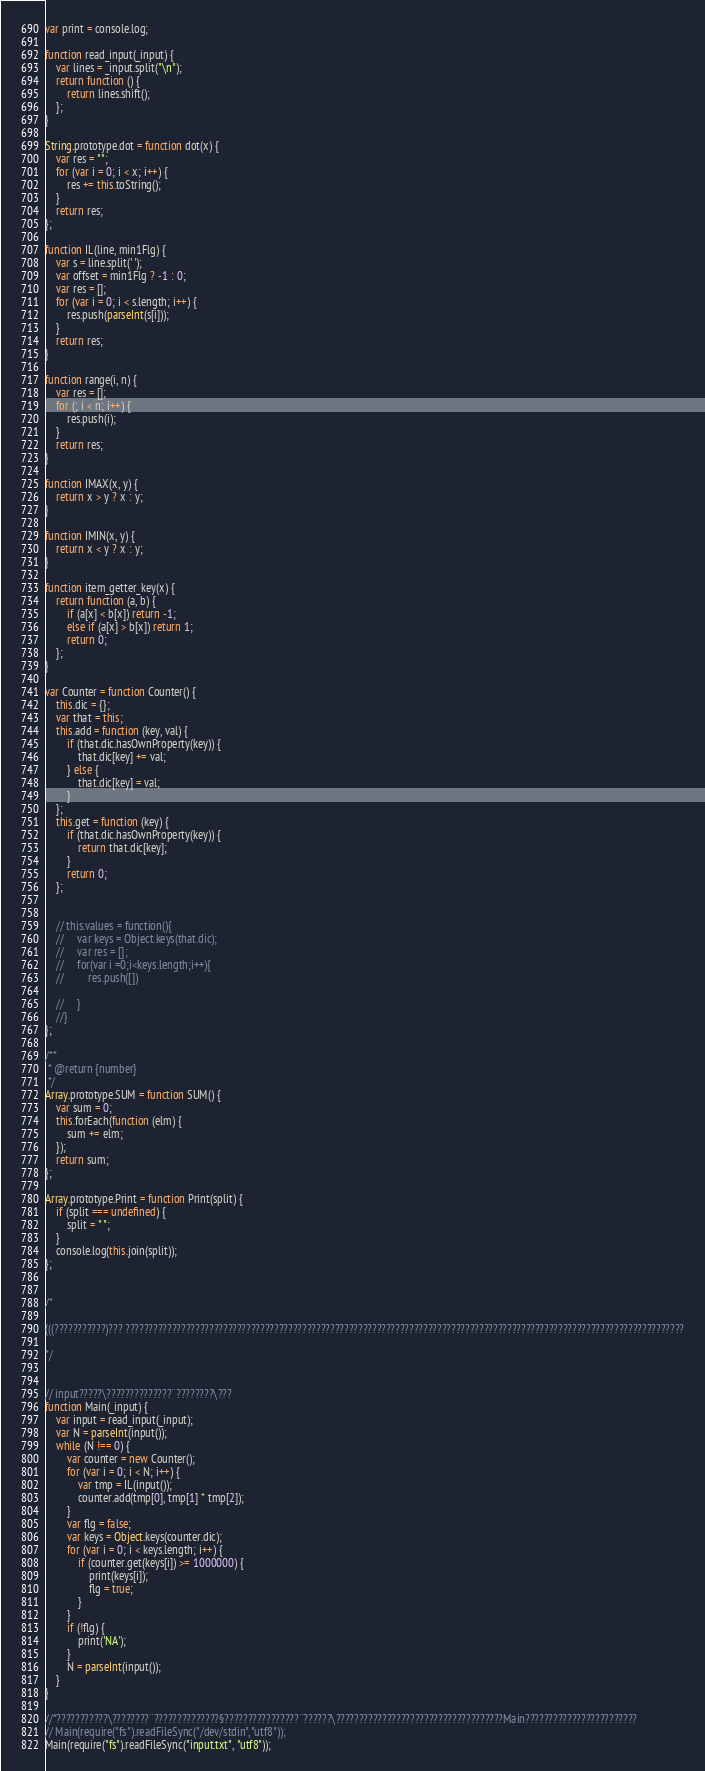<code> <loc_0><loc_0><loc_500><loc_500><_JavaScript_>var print = console.log;

function read_input(_input) {
    var lines = _input.split("\n");
    return function () {
        return lines.shift();
    };
}

String.prototype.dot = function dot(x) {
    var res = "";
    for (var i = 0; i < x; i++) {
        res += this.toString();
    }
    return res;
};

function IL(line, min1Flg) {
    var s = line.split(' ');
    var offset = min1Flg ? -1 : 0;
    var res = [];
    for (var i = 0; i < s.length; i++) {
        res.push(parseInt(s[i]));
    }
    return res;
}

function range(i, n) {
    var res = [];
    for (; i < n; i++) {
        res.push(i);
    }
    return res;
}

function IMAX(x, y) {
    return x > y ? x : y;
}

function IMIN(x, y) {
    return x < y ? x : y;
}

function item_getter_key(x) {
    return function (a, b) {
        if (a[x] < b[x]) return -1;
        else if (a[x] > b[x]) return 1;
        return 0;
    };
}

var Counter = function Counter() {
    this.dic = {};
    var that = this;
    this.add = function (key, val) {
        if (that.dic.hasOwnProperty(key)) {
            that.dic[key] += val;
        } else {
            that.dic[key] = val;
        }
    };
    this.get = function (key) {
        if (that.dic.hasOwnProperty(key)) {
            return that.dic[key];
        }
        return 0;
    };


    // this.values = function(){
    //     var keys = Object.keys(that.dic);
    //     var res = [];
    //     for(var i =0;i<keys.length;i++){
    //         res.push([])

    //     }
    //}
};

/**
 * @return {number}
 */
Array.prototype.SUM = function SUM() {
    var sum = 0;
    this.forEach(function (elm) {
        sum += elm;
    });
    return sum;
};

Array.prototype.Print = function Print(split) {
    if (split === undefined) {
        split = " ";
    }
    console.log(this.join(split));
};


/*

(((???????????)??? ????????????????????????????????????????????????????????????????????????????????????????????????????????????????????????

*/


// input?????\??????????????¨????????\???
function Main(_input) {
    var input = read_input(_input);
    var N = parseInt(input());
    while (N !== 0) {
        var counter = new Counter();
        for (var i = 0; i < N; i++) {
            var tmp = IL(input());
            counter.add(tmp[0], tmp[1] * tmp[2]);
        }
        var flg = false;
        var keys = Object.keys(counter.dic);
        for (var i = 0; i < keys.length; i++) {
            if (counter.get(keys[i]) >= 1000000) {
                print(keys[i]);
                flg = true;
            }
        }
        if (!flg) {
            print('NA');
        }
        N = parseInt(input());
    }
}

//*???????????\????????¨??????????????§????????????????¨??????\????????????????????????????????????Main????????????????????????
// Main(require("fs").readFileSync("/dev/stdin", "utf8"));
Main(require("fs").readFileSync("input.txt", "utf8"));</code> 